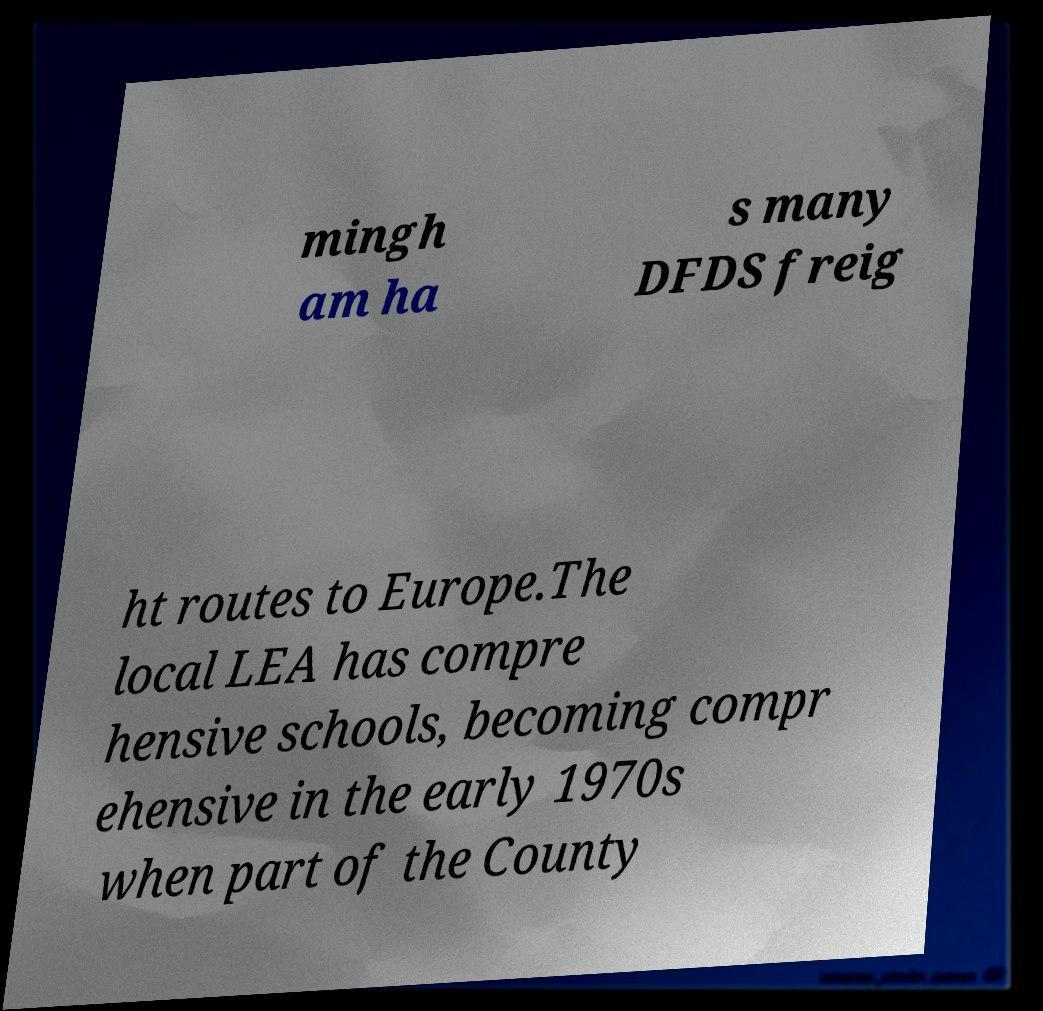I need the written content from this picture converted into text. Can you do that? mingh am ha s many DFDS freig ht routes to Europe.The local LEA has compre hensive schools, becoming compr ehensive in the early 1970s when part of the County 